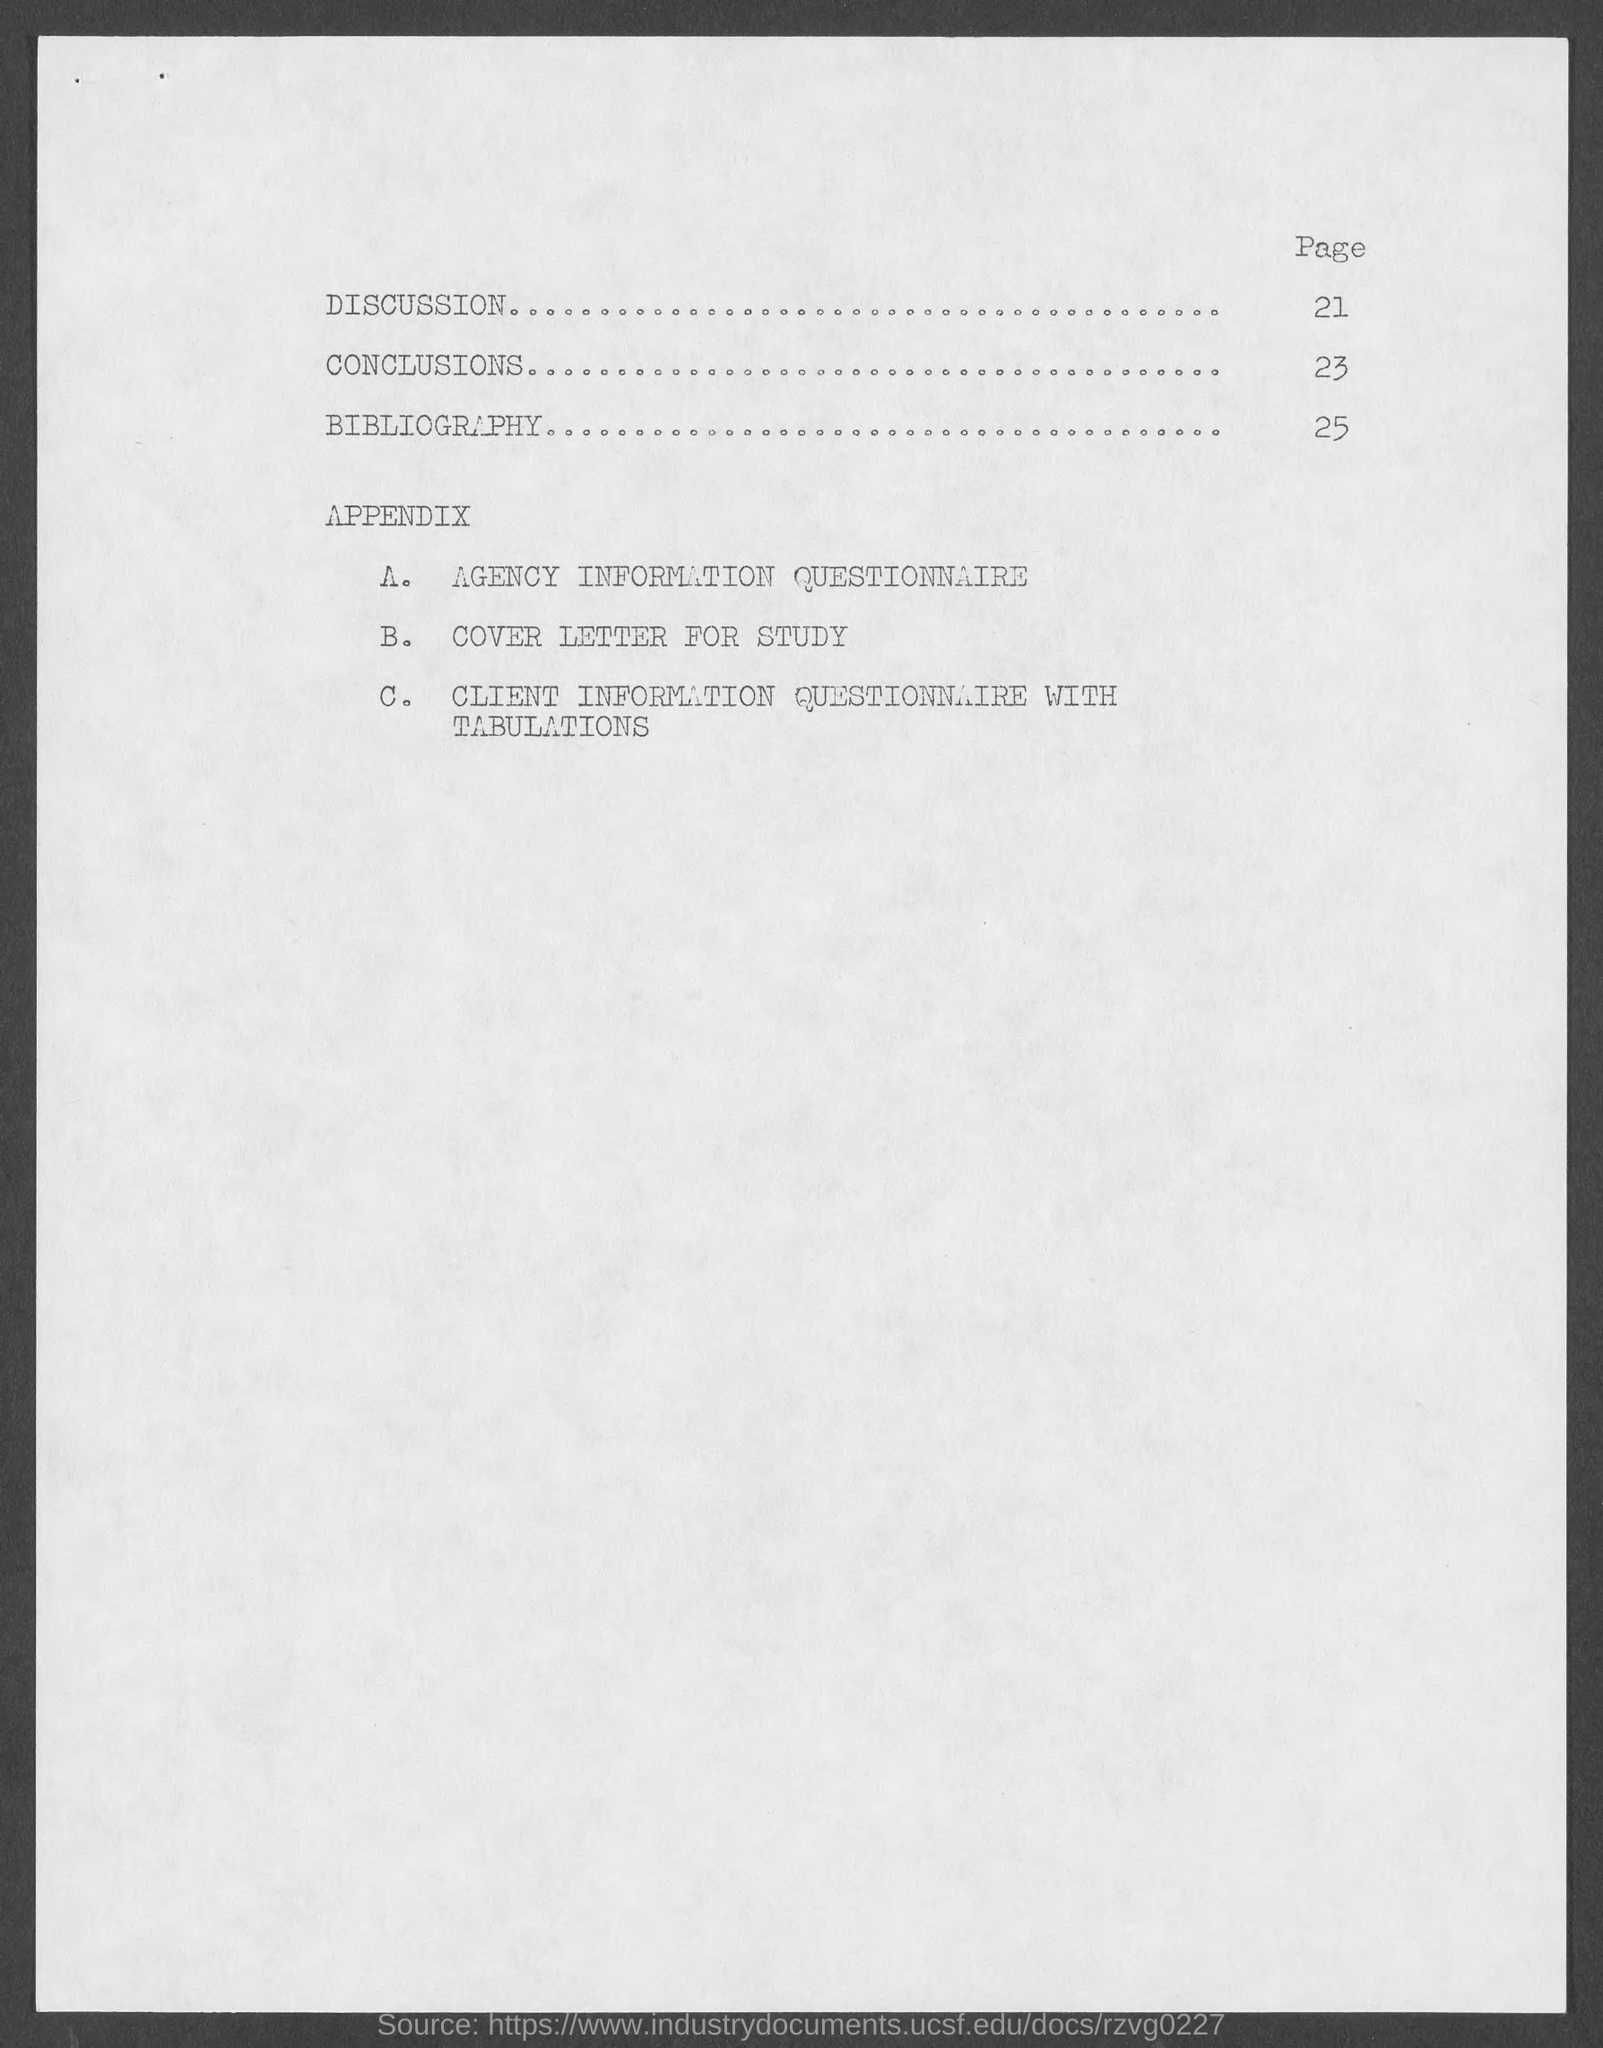What is the page number for discussion ?
Offer a terse response. 21. What is the page number for conclusion ?
Provide a short and direct response. 23. What is the page number for bibliography ?
Offer a very short reply. 25. 